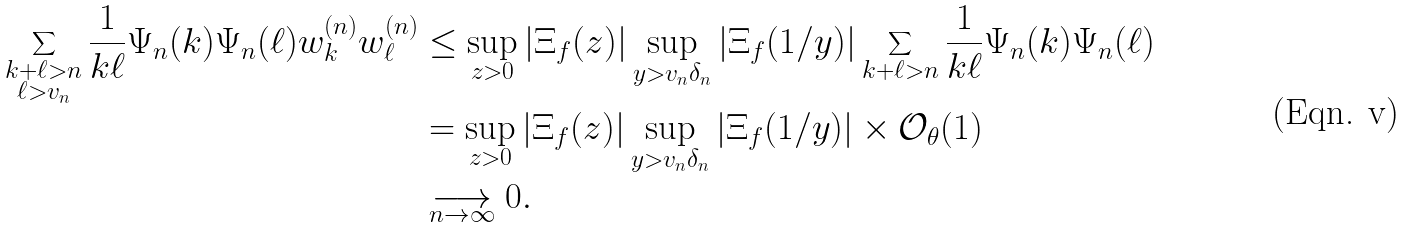<formula> <loc_0><loc_0><loc_500><loc_500>\sum _ { \substack { k + \ell > n \\ \ell > v _ { n } } } \frac { 1 } { k \ell } \Psi _ { n } ( k ) \Psi _ { n } ( \ell ) w _ { k } ^ { ( n ) } w _ { \ell } ^ { ( n ) } & \leq \sup _ { z > 0 } | \Xi _ { f } ( z ) | \sup _ { y > v _ { n } \delta _ { n } } | \Xi _ { f } ( 1 / y ) | \sum _ { k + \ell > n } \frac { 1 } { k \ell } \Psi _ { n } ( k ) \Psi _ { n } ( \ell ) \\ & = \sup _ { z > 0 } | \Xi _ { f } ( z ) | \sup _ { y > v _ { n } \delta _ { n } } | \Xi _ { f } ( 1 / y ) | \times \mathcal { O } _ { \theta } ( 1 ) \\ & \underset { n \to \infty } { \longrightarrow } 0 .</formula> 